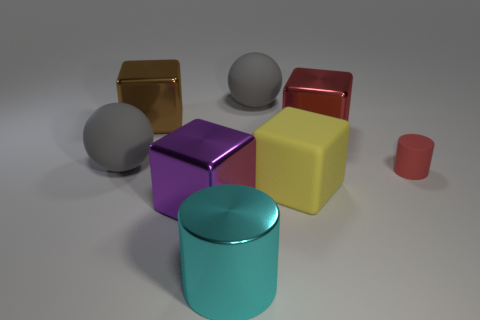Subtract all big purple metal blocks. How many blocks are left? 3 Add 1 brown metallic cubes. How many objects exist? 9 Subtract all red cubes. How many cubes are left? 3 Subtract 1 cylinders. How many cylinders are left? 1 Subtract all cylinders. How many objects are left? 6 Subtract all red cubes. Subtract all yellow cylinders. How many cubes are left? 3 Add 1 big purple metallic things. How many big purple metallic things exist? 2 Subtract 0 blue blocks. How many objects are left? 8 Subtract all purple blocks. Subtract all purple metal blocks. How many objects are left? 6 Add 5 cyan metallic things. How many cyan metallic things are left? 6 